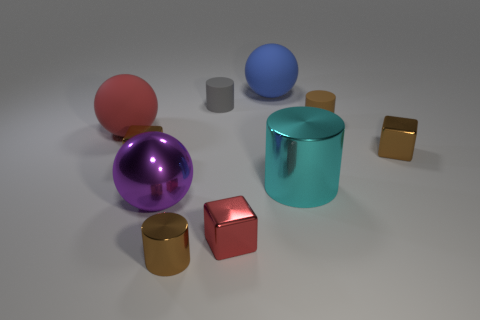What material is the small gray thing that is the same shape as the large cyan object?
Provide a succinct answer. Rubber. Do the metallic sphere and the blue rubber ball left of the large metal cylinder have the same size?
Offer a terse response. Yes. Is the number of small gray rubber objects that are on the left side of the purple metallic object the same as the number of spheres behind the red ball?
Your response must be concise. No. The tiny matte object that is the same color as the small metallic cylinder is what shape?
Ensure brevity in your answer.  Cylinder. There is a ball on the right side of the tiny red block; what is it made of?
Your response must be concise. Rubber. Do the cyan thing and the gray matte cylinder have the same size?
Keep it short and to the point. No. Are there more brown rubber things that are to the right of the red metal thing than big cyan rubber spheres?
Provide a short and direct response. Yes. There is a ball that is made of the same material as the big cyan cylinder; what is its size?
Your answer should be compact. Large. Are there any rubber objects behind the brown rubber cylinder?
Your answer should be compact. Yes. Is the large blue rubber thing the same shape as the big red thing?
Provide a short and direct response. Yes. 